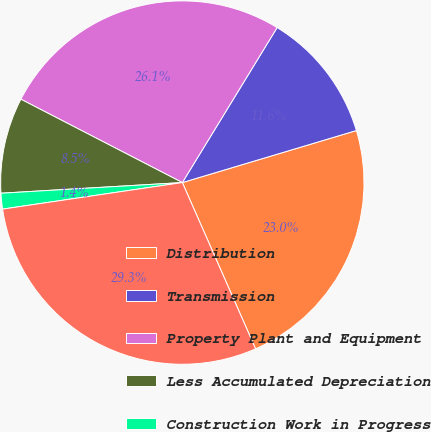<chart> <loc_0><loc_0><loc_500><loc_500><pie_chart><fcel>Distribution<fcel>Transmission<fcel>Property Plant and Equipment<fcel>Less Accumulated Depreciation<fcel>Construction Work in Progress<fcel>Total Property Plant and<nl><fcel>23.02%<fcel>11.64%<fcel>26.15%<fcel>8.52%<fcel>1.4%<fcel>29.27%<nl></chart> 